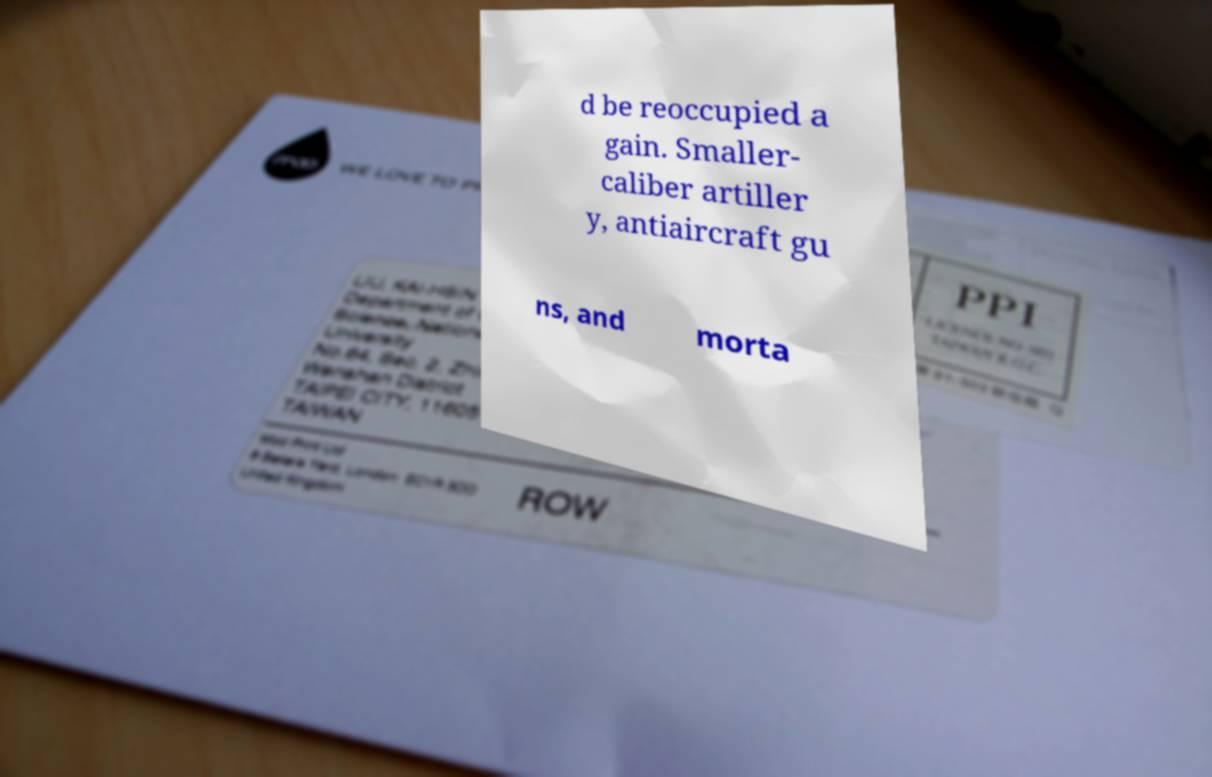Can you read and provide the text displayed in the image?This photo seems to have some interesting text. Can you extract and type it out for me? d be reoccupied a gain. Smaller- caliber artiller y, antiaircraft gu ns, and morta 